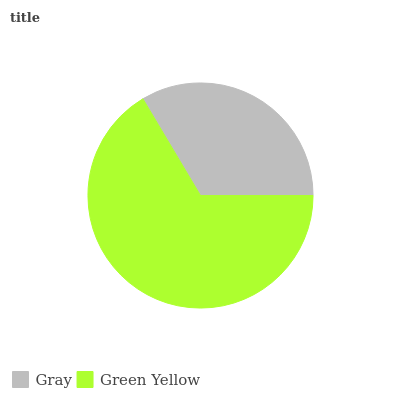Is Gray the minimum?
Answer yes or no. Yes. Is Green Yellow the maximum?
Answer yes or no. Yes. Is Green Yellow the minimum?
Answer yes or no. No. Is Green Yellow greater than Gray?
Answer yes or no. Yes. Is Gray less than Green Yellow?
Answer yes or no. Yes. Is Gray greater than Green Yellow?
Answer yes or no. No. Is Green Yellow less than Gray?
Answer yes or no. No. Is Green Yellow the high median?
Answer yes or no. Yes. Is Gray the low median?
Answer yes or no. Yes. Is Gray the high median?
Answer yes or no. No. Is Green Yellow the low median?
Answer yes or no. No. 